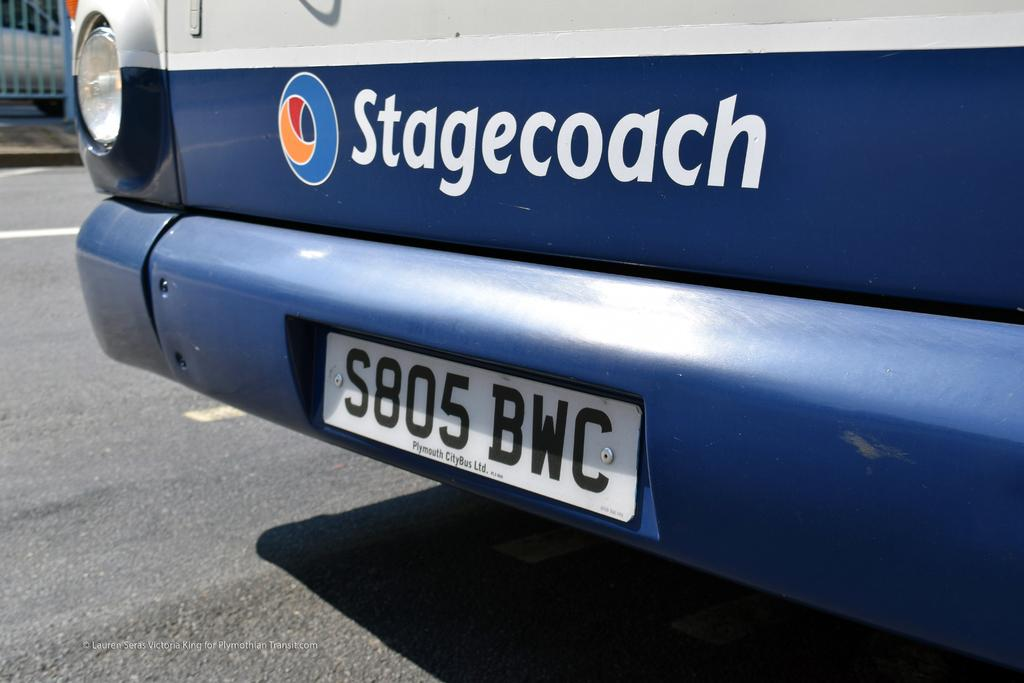<image>
Share a concise interpretation of the image provided. Blue car with the word Stagecoach on the back. 